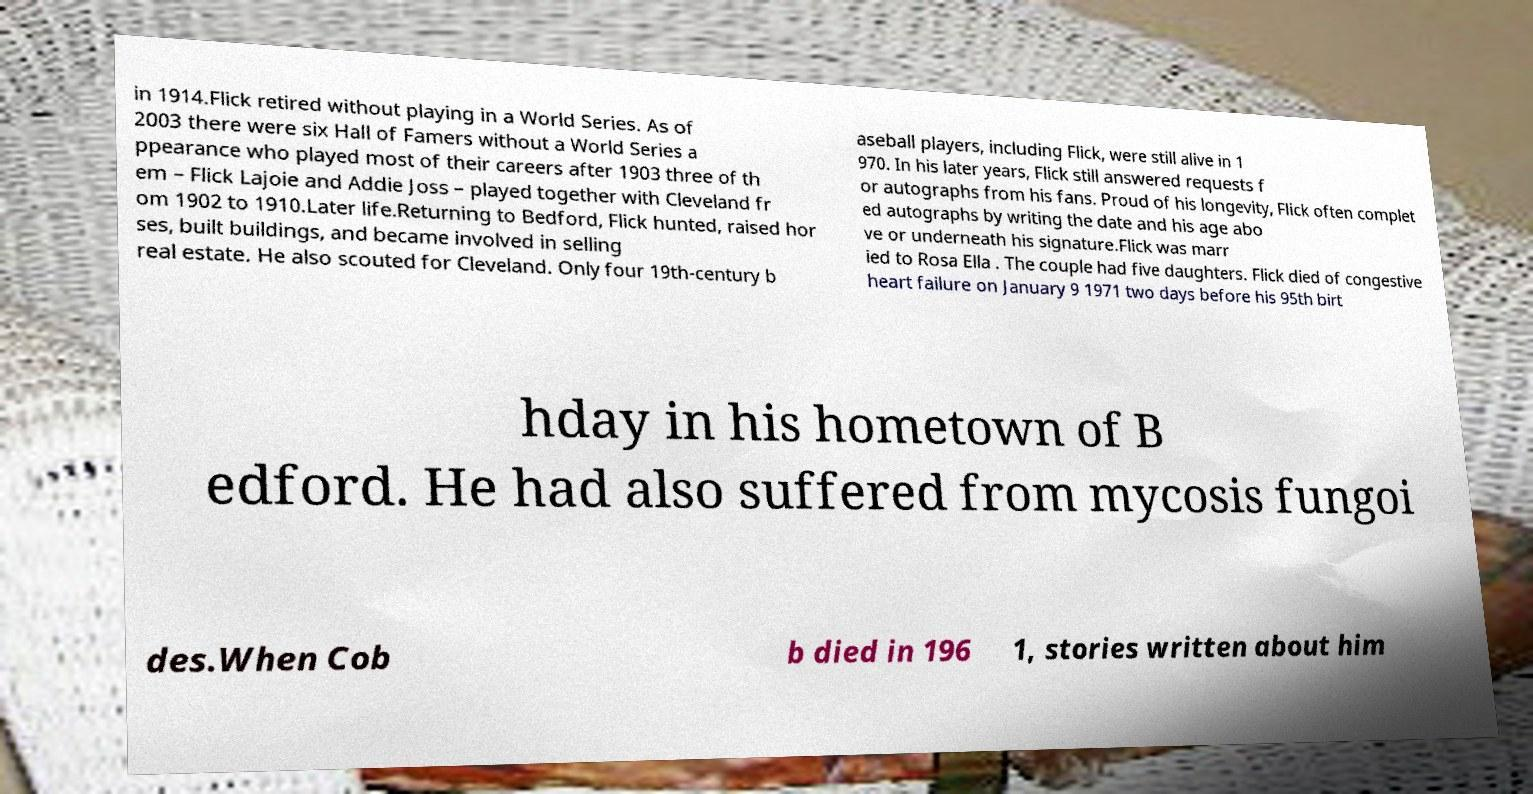Could you extract and type out the text from this image? in 1914.Flick retired without playing in a World Series. As of 2003 there were six Hall of Famers without a World Series a ppearance who played most of their careers after 1903 three of th em – Flick Lajoie and Addie Joss – played together with Cleveland fr om 1902 to 1910.Later life.Returning to Bedford, Flick hunted, raised hor ses, built buildings, and became involved in selling real estate. He also scouted for Cleveland. Only four 19th-century b aseball players, including Flick, were still alive in 1 970. In his later years, Flick still answered requests f or autographs from his fans. Proud of his longevity, Flick often complet ed autographs by writing the date and his age abo ve or underneath his signature.Flick was marr ied to Rosa Ella . The couple had five daughters. Flick died of congestive heart failure on January 9 1971 two days before his 95th birt hday in his hometown of B edford. He had also suffered from mycosis fungoi des.When Cob b died in 196 1, stories written about him 